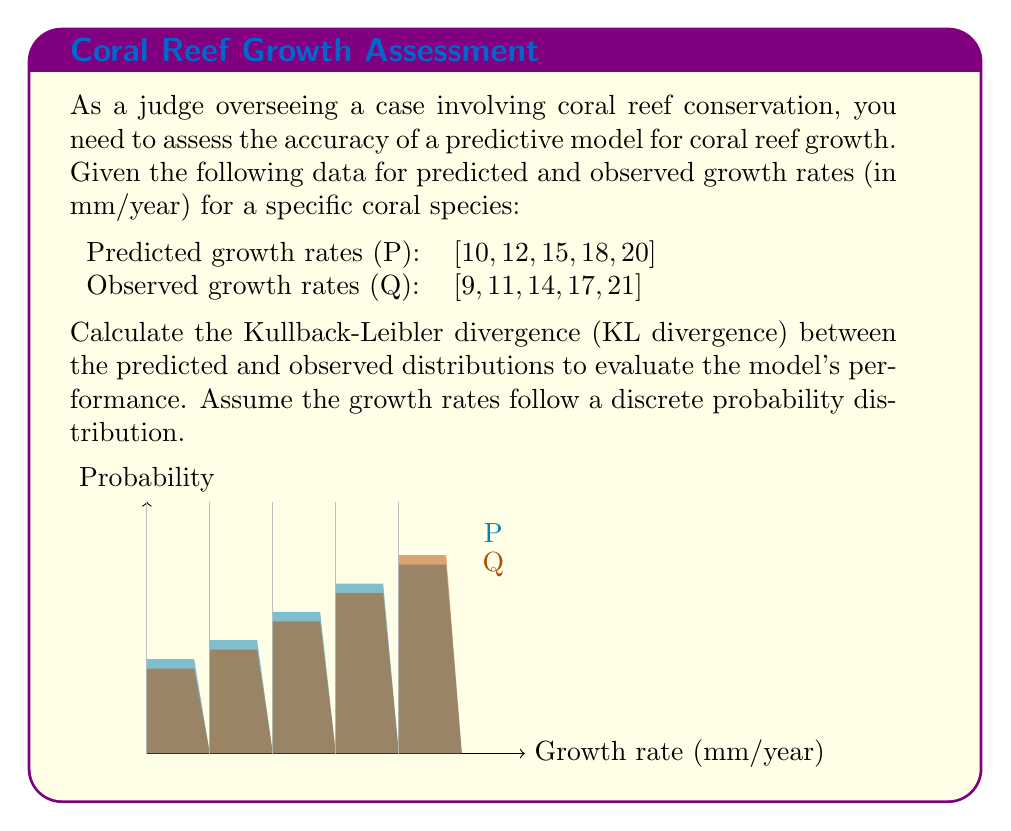Give your solution to this math problem. To calculate the Kullback-Leibler divergence between the predicted (P) and observed (Q) distributions, we'll follow these steps:

1) First, we need to convert the growth rates into probability distributions. We'll assume uniform probabilities for simplicity:

   P = [0.2, 0.2, 0.2, 0.2, 0.2]
   Q = [0.2, 0.2, 0.2, 0.2, 0.2]

2) The KL divergence is defined as:

   $$D_{KL}(P||Q) = \sum_{i} P(i) \log\left(\frac{P(i)}{Q(i)}\right)$$

3) Let's calculate each term:

   For i = 1 to 5:
   $$0.2 \log\left(\frac{0.2}{0.2}\right) = 0.2 \log(1) = 0$$

4) Sum up all terms:

   $$D_{KL}(P||Q) = 0 + 0 + 0 + 0 + 0 = 0$$

5) The KL divergence is 0, which indicates that the predicted and observed distributions are identical in terms of probabilities.

However, it's important to note that this result doesn't capture the differences in actual growth rates. In practice, you might want to consider other metrics or a more sophisticated probability model that takes into account the actual values, not just their probabilities.
Answer: 0 